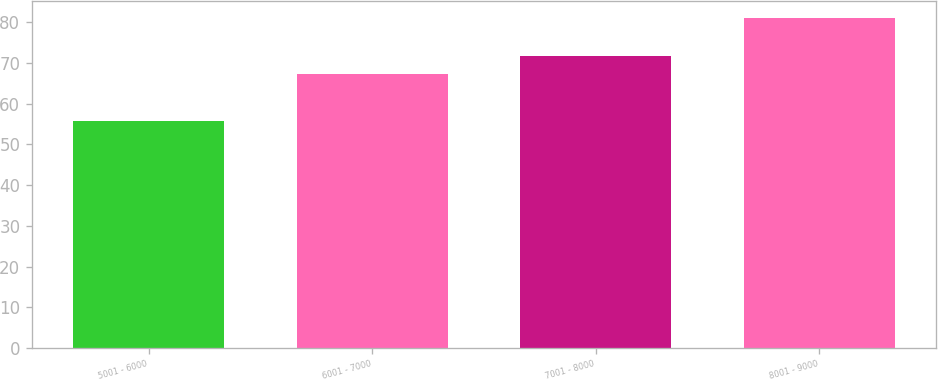Convert chart. <chart><loc_0><loc_0><loc_500><loc_500><bar_chart><fcel>5001 - 6000<fcel>6001 - 7000<fcel>7001 - 8000<fcel>8001 - 9000<nl><fcel>55.83<fcel>67.18<fcel>71.7<fcel>81.13<nl></chart> 